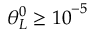<formula> <loc_0><loc_0><loc_500><loc_500>\theta _ { L } ^ { 0 } \geq { { 1 0 } ^ { - 5 } }</formula> 